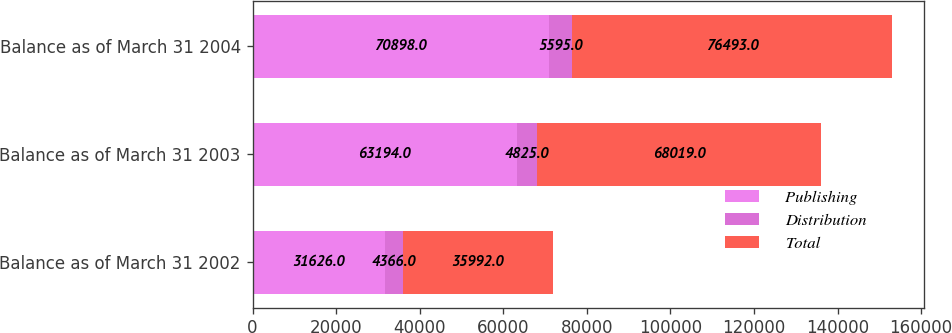<chart> <loc_0><loc_0><loc_500><loc_500><stacked_bar_chart><ecel><fcel>Balance as of March 31 2002<fcel>Balance as of March 31 2003<fcel>Balance as of March 31 2004<nl><fcel>Publishing<fcel>31626<fcel>63194<fcel>70898<nl><fcel>Distribution<fcel>4366<fcel>4825<fcel>5595<nl><fcel>Total<fcel>35992<fcel>68019<fcel>76493<nl></chart> 